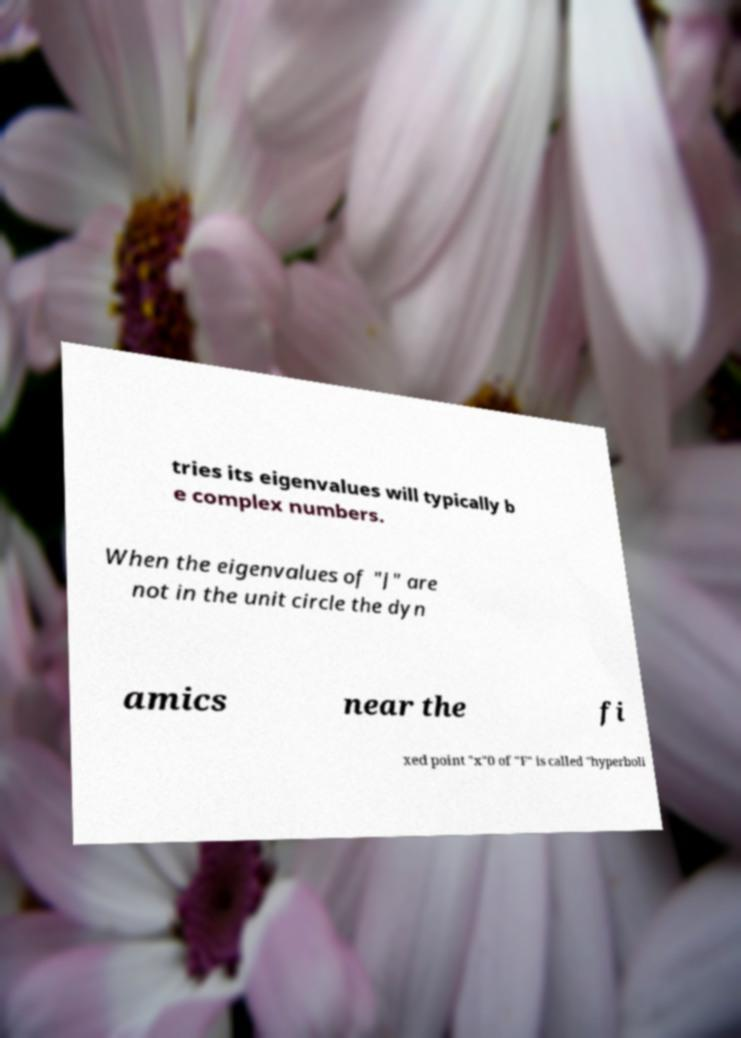Can you accurately transcribe the text from the provided image for me? tries its eigenvalues will typically b e complex numbers. When the eigenvalues of "J" are not in the unit circle the dyn amics near the fi xed point "x"0 of "F" is called "hyperboli 